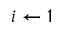Convert formula to latex. <formula><loc_0><loc_0><loc_500><loc_500>i \gets 1</formula> 